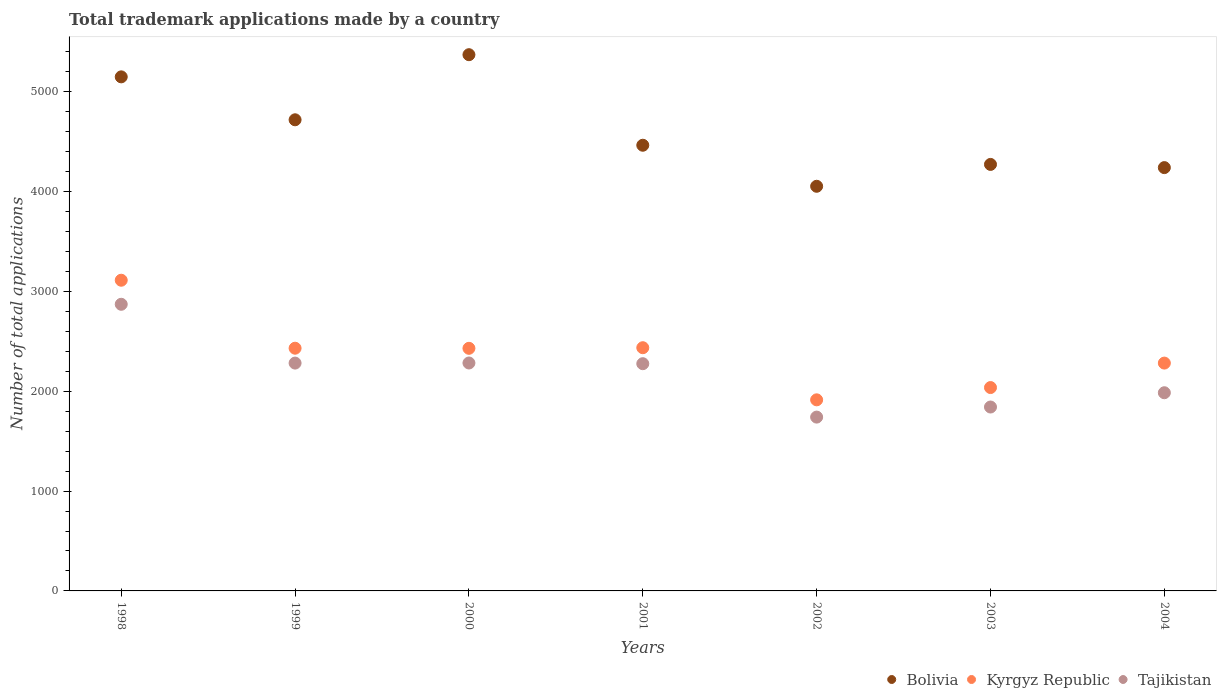Is the number of dotlines equal to the number of legend labels?
Provide a succinct answer. Yes. What is the number of applications made by in Bolivia in 2002?
Provide a succinct answer. 4053. Across all years, what is the maximum number of applications made by in Kyrgyz Republic?
Your answer should be compact. 3112. Across all years, what is the minimum number of applications made by in Tajikistan?
Make the answer very short. 1741. In which year was the number of applications made by in Kyrgyz Republic minimum?
Your answer should be very brief. 2002. What is the total number of applications made by in Kyrgyz Republic in the graph?
Provide a succinct answer. 1.66e+04. What is the difference between the number of applications made by in Tajikistan in 2000 and that in 2003?
Provide a short and direct response. 441. What is the difference between the number of applications made by in Bolivia in 1999 and the number of applications made by in Kyrgyz Republic in 2001?
Provide a short and direct response. 2283. What is the average number of applications made by in Bolivia per year?
Give a very brief answer. 4609.71. In the year 2001, what is the difference between the number of applications made by in Bolivia and number of applications made by in Tajikistan?
Your answer should be compact. 2188. In how many years, is the number of applications made by in Tajikistan greater than 600?
Keep it short and to the point. 7. What is the ratio of the number of applications made by in Bolivia in 1998 to that in 2002?
Offer a very short reply. 1.27. Is the difference between the number of applications made by in Bolivia in 1998 and 1999 greater than the difference between the number of applications made by in Tajikistan in 1998 and 1999?
Ensure brevity in your answer.  No. What is the difference between the highest and the second highest number of applications made by in Kyrgyz Republic?
Offer a very short reply. 676. What is the difference between the highest and the lowest number of applications made by in Tajikistan?
Your answer should be very brief. 1130. In how many years, is the number of applications made by in Tajikistan greater than the average number of applications made by in Tajikistan taken over all years?
Offer a terse response. 4. Is the number of applications made by in Tajikistan strictly less than the number of applications made by in Kyrgyz Republic over the years?
Your response must be concise. Yes. Does the graph contain any zero values?
Make the answer very short. No. Where does the legend appear in the graph?
Give a very brief answer. Bottom right. How many legend labels are there?
Keep it short and to the point. 3. How are the legend labels stacked?
Provide a succinct answer. Horizontal. What is the title of the graph?
Offer a very short reply. Total trademark applications made by a country. Does "Middle East & North Africa (developing only)" appear as one of the legend labels in the graph?
Keep it short and to the point. No. What is the label or title of the X-axis?
Provide a short and direct response. Years. What is the label or title of the Y-axis?
Your answer should be very brief. Number of total applications. What is the Number of total applications in Bolivia in 1998?
Keep it short and to the point. 5149. What is the Number of total applications of Kyrgyz Republic in 1998?
Give a very brief answer. 3112. What is the Number of total applications of Tajikistan in 1998?
Provide a short and direct response. 2871. What is the Number of total applications in Bolivia in 1999?
Offer a terse response. 4719. What is the Number of total applications of Kyrgyz Republic in 1999?
Offer a terse response. 2431. What is the Number of total applications of Tajikistan in 1999?
Provide a short and direct response. 2282. What is the Number of total applications of Bolivia in 2000?
Keep it short and to the point. 5371. What is the Number of total applications in Kyrgyz Republic in 2000?
Keep it short and to the point. 2430. What is the Number of total applications in Tajikistan in 2000?
Your answer should be very brief. 2283. What is the Number of total applications of Bolivia in 2001?
Offer a very short reply. 4464. What is the Number of total applications of Kyrgyz Republic in 2001?
Provide a succinct answer. 2436. What is the Number of total applications of Tajikistan in 2001?
Your answer should be compact. 2276. What is the Number of total applications of Bolivia in 2002?
Provide a succinct answer. 4053. What is the Number of total applications in Kyrgyz Republic in 2002?
Your answer should be very brief. 1914. What is the Number of total applications of Tajikistan in 2002?
Give a very brief answer. 1741. What is the Number of total applications of Bolivia in 2003?
Provide a short and direct response. 4272. What is the Number of total applications in Kyrgyz Republic in 2003?
Offer a very short reply. 2037. What is the Number of total applications in Tajikistan in 2003?
Keep it short and to the point. 1842. What is the Number of total applications of Bolivia in 2004?
Your answer should be very brief. 4240. What is the Number of total applications of Kyrgyz Republic in 2004?
Make the answer very short. 2282. What is the Number of total applications in Tajikistan in 2004?
Provide a short and direct response. 1985. Across all years, what is the maximum Number of total applications of Bolivia?
Ensure brevity in your answer.  5371. Across all years, what is the maximum Number of total applications in Kyrgyz Republic?
Ensure brevity in your answer.  3112. Across all years, what is the maximum Number of total applications in Tajikistan?
Offer a very short reply. 2871. Across all years, what is the minimum Number of total applications in Bolivia?
Your answer should be compact. 4053. Across all years, what is the minimum Number of total applications of Kyrgyz Republic?
Provide a succinct answer. 1914. Across all years, what is the minimum Number of total applications of Tajikistan?
Your answer should be very brief. 1741. What is the total Number of total applications in Bolivia in the graph?
Give a very brief answer. 3.23e+04. What is the total Number of total applications in Kyrgyz Republic in the graph?
Your answer should be compact. 1.66e+04. What is the total Number of total applications of Tajikistan in the graph?
Your response must be concise. 1.53e+04. What is the difference between the Number of total applications of Bolivia in 1998 and that in 1999?
Your answer should be very brief. 430. What is the difference between the Number of total applications of Kyrgyz Republic in 1998 and that in 1999?
Offer a very short reply. 681. What is the difference between the Number of total applications of Tajikistan in 1998 and that in 1999?
Keep it short and to the point. 589. What is the difference between the Number of total applications of Bolivia in 1998 and that in 2000?
Provide a short and direct response. -222. What is the difference between the Number of total applications in Kyrgyz Republic in 1998 and that in 2000?
Give a very brief answer. 682. What is the difference between the Number of total applications of Tajikistan in 1998 and that in 2000?
Provide a short and direct response. 588. What is the difference between the Number of total applications of Bolivia in 1998 and that in 2001?
Ensure brevity in your answer.  685. What is the difference between the Number of total applications in Kyrgyz Republic in 1998 and that in 2001?
Make the answer very short. 676. What is the difference between the Number of total applications of Tajikistan in 1998 and that in 2001?
Your answer should be compact. 595. What is the difference between the Number of total applications in Bolivia in 1998 and that in 2002?
Provide a short and direct response. 1096. What is the difference between the Number of total applications in Kyrgyz Republic in 1998 and that in 2002?
Your answer should be very brief. 1198. What is the difference between the Number of total applications of Tajikistan in 1998 and that in 2002?
Keep it short and to the point. 1130. What is the difference between the Number of total applications in Bolivia in 1998 and that in 2003?
Give a very brief answer. 877. What is the difference between the Number of total applications of Kyrgyz Republic in 1998 and that in 2003?
Keep it short and to the point. 1075. What is the difference between the Number of total applications in Tajikistan in 1998 and that in 2003?
Provide a short and direct response. 1029. What is the difference between the Number of total applications of Bolivia in 1998 and that in 2004?
Provide a short and direct response. 909. What is the difference between the Number of total applications in Kyrgyz Republic in 1998 and that in 2004?
Your answer should be compact. 830. What is the difference between the Number of total applications of Tajikistan in 1998 and that in 2004?
Your response must be concise. 886. What is the difference between the Number of total applications in Bolivia in 1999 and that in 2000?
Provide a succinct answer. -652. What is the difference between the Number of total applications in Kyrgyz Republic in 1999 and that in 2000?
Provide a succinct answer. 1. What is the difference between the Number of total applications of Tajikistan in 1999 and that in 2000?
Your answer should be compact. -1. What is the difference between the Number of total applications in Bolivia in 1999 and that in 2001?
Your answer should be compact. 255. What is the difference between the Number of total applications in Kyrgyz Republic in 1999 and that in 2001?
Make the answer very short. -5. What is the difference between the Number of total applications of Bolivia in 1999 and that in 2002?
Give a very brief answer. 666. What is the difference between the Number of total applications in Kyrgyz Republic in 1999 and that in 2002?
Your response must be concise. 517. What is the difference between the Number of total applications of Tajikistan in 1999 and that in 2002?
Provide a succinct answer. 541. What is the difference between the Number of total applications of Bolivia in 1999 and that in 2003?
Ensure brevity in your answer.  447. What is the difference between the Number of total applications in Kyrgyz Republic in 1999 and that in 2003?
Your answer should be very brief. 394. What is the difference between the Number of total applications of Tajikistan in 1999 and that in 2003?
Ensure brevity in your answer.  440. What is the difference between the Number of total applications in Bolivia in 1999 and that in 2004?
Provide a short and direct response. 479. What is the difference between the Number of total applications of Kyrgyz Republic in 1999 and that in 2004?
Provide a succinct answer. 149. What is the difference between the Number of total applications of Tajikistan in 1999 and that in 2004?
Your answer should be very brief. 297. What is the difference between the Number of total applications in Bolivia in 2000 and that in 2001?
Provide a short and direct response. 907. What is the difference between the Number of total applications of Tajikistan in 2000 and that in 2001?
Offer a very short reply. 7. What is the difference between the Number of total applications of Bolivia in 2000 and that in 2002?
Give a very brief answer. 1318. What is the difference between the Number of total applications in Kyrgyz Republic in 2000 and that in 2002?
Provide a short and direct response. 516. What is the difference between the Number of total applications of Tajikistan in 2000 and that in 2002?
Offer a terse response. 542. What is the difference between the Number of total applications in Bolivia in 2000 and that in 2003?
Offer a very short reply. 1099. What is the difference between the Number of total applications in Kyrgyz Republic in 2000 and that in 2003?
Offer a terse response. 393. What is the difference between the Number of total applications of Tajikistan in 2000 and that in 2003?
Offer a very short reply. 441. What is the difference between the Number of total applications of Bolivia in 2000 and that in 2004?
Provide a succinct answer. 1131. What is the difference between the Number of total applications of Kyrgyz Republic in 2000 and that in 2004?
Keep it short and to the point. 148. What is the difference between the Number of total applications of Tajikistan in 2000 and that in 2004?
Your answer should be very brief. 298. What is the difference between the Number of total applications of Bolivia in 2001 and that in 2002?
Offer a terse response. 411. What is the difference between the Number of total applications of Kyrgyz Republic in 2001 and that in 2002?
Offer a very short reply. 522. What is the difference between the Number of total applications of Tajikistan in 2001 and that in 2002?
Your answer should be compact. 535. What is the difference between the Number of total applications of Bolivia in 2001 and that in 2003?
Keep it short and to the point. 192. What is the difference between the Number of total applications of Kyrgyz Republic in 2001 and that in 2003?
Your response must be concise. 399. What is the difference between the Number of total applications in Tajikistan in 2001 and that in 2003?
Your answer should be very brief. 434. What is the difference between the Number of total applications in Bolivia in 2001 and that in 2004?
Ensure brevity in your answer.  224. What is the difference between the Number of total applications in Kyrgyz Republic in 2001 and that in 2004?
Offer a very short reply. 154. What is the difference between the Number of total applications in Tajikistan in 2001 and that in 2004?
Your response must be concise. 291. What is the difference between the Number of total applications of Bolivia in 2002 and that in 2003?
Keep it short and to the point. -219. What is the difference between the Number of total applications of Kyrgyz Republic in 2002 and that in 2003?
Your answer should be very brief. -123. What is the difference between the Number of total applications of Tajikistan in 2002 and that in 2003?
Make the answer very short. -101. What is the difference between the Number of total applications in Bolivia in 2002 and that in 2004?
Provide a short and direct response. -187. What is the difference between the Number of total applications in Kyrgyz Republic in 2002 and that in 2004?
Ensure brevity in your answer.  -368. What is the difference between the Number of total applications in Tajikistan in 2002 and that in 2004?
Your response must be concise. -244. What is the difference between the Number of total applications in Bolivia in 2003 and that in 2004?
Make the answer very short. 32. What is the difference between the Number of total applications in Kyrgyz Republic in 2003 and that in 2004?
Your answer should be very brief. -245. What is the difference between the Number of total applications of Tajikistan in 2003 and that in 2004?
Give a very brief answer. -143. What is the difference between the Number of total applications in Bolivia in 1998 and the Number of total applications in Kyrgyz Republic in 1999?
Your answer should be compact. 2718. What is the difference between the Number of total applications of Bolivia in 1998 and the Number of total applications of Tajikistan in 1999?
Your answer should be compact. 2867. What is the difference between the Number of total applications of Kyrgyz Republic in 1998 and the Number of total applications of Tajikistan in 1999?
Offer a terse response. 830. What is the difference between the Number of total applications of Bolivia in 1998 and the Number of total applications of Kyrgyz Republic in 2000?
Your response must be concise. 2719. What is the difference between the Number of total applications of Bolivia in 1998 and the Number of total applications of Tajikistan in 2000?
Give a very brief answer. 2866. What is the difference between the Number of total applications in Kyrgyz Republic in 1998 and the Number of total applications in Tajikistan in 2000?
Make the answer very short. 829. What is the difference between the Number of total applications in Bolivia in 1998 and the Number of total applications in Kyrgyz Republic in 2001?
Ensure brevity in your answer.  2713. What is the difference between the Number of total applications of Bolivia in 1998 and the Number of total applications of Tajikistan in 2001?
Provide a short and direct response. 2873. What is the difference between the Number of total applications in Kyrgyz Republic in 1998 and the Number of total applications in Tajikistan in 2001?
Keep it short and to the point. 836. What is the difference between the Number of total applications of Bolivia in 1998 and the Number of total applications of Kyrgyz Republic in 2002?
Make the answer very short. 3235. What is the difference between the Number of total applications of Bolivia in 1998 and the Number of total applications of Tajikistan in 2002?
Offer a terse response. 3408. What is the difference between the Number of total applications of Kyrgyz Republic in 1998 and the Number of total applications of Tajikistan in 2002?
Offer a terse response. 1371. What is the difference between the Number of total applications in Bolivia in 1998 and the Number of total applications in Kyrgyz Republic in 2003?
Your answer should be very brief. 3112. What is the difference between the Number of total applications in Bolivia in 1998 and the Number of total applications in Tajikistan in 2003?
Keep it short and to the point. 3307. What is the difference between the Number of total applications of Kyrgyz Republic in 1998 and the Number of total applications of Tajikistan in 2003?
Provide a short and direct response. 1270. What is the difference between the Number of total applications in Bolivia in 1998 and the Number of total applications in Kyrgyz Republic in 2004?
Give a very brief answer. 2867. What is the difference between the Number of total applications of Bolivia in 1998 and the Number of total applications of Tajikistan in 2004?
Give a very brief answer. 3164. What is the difference between the Number of total applications in Kyrgyz Republic in 1998 and the Number of total applications in Tajikistan in 2004?
Provide a succinct answer. 1127. What is the difference between the Number of total applications in Bolivia in 1999 and the Number of total applications in Kyrgyz Republic in 2000?
Your answer should be very brief. 2289. What is the difference between the Number of total applications of Bolivia in 1999 and the Number of total applications of Tajikistan in 2000?
Make the answer very short. 2436. What is the difference between the Number of total applications in Kyrgyz Republic in 1999 and the Number of total applications in Tajikistan in 2000?
Offer a very short reply. 148. What is the difference between the Number of total applications of Bolivia in 1999 and the Number of total applications of Kyrgyz Republic in 2001?
Provide a succinct answer. 2283. What is the difference between the Number of total applications of Bolivia in 1999 and the Number of total applications of Tajikistan in 2001?
Your response must be concise. 2443. What is the difference between the Number of total applications of Kyrgyz Republic in 1999 and the Number of total applications of Tajikistan in 2001?
Your answer should be very brief. 155. What is the difference between the Number of total applications in Bolivia in 1999 and the Number of total applications in Kyrgyz Republic in 2002?
Offer a very short reply. 2805. What is the difference between the Number of total applications in Bolivia in 1999 and the Number of total applications in Tajikistan in 2002?
Your answer should be very brief. 2978. What is the difference between the Number of total applications of Kyrgyz Republic in 1999 and the Number of total applications of Tajikistan in 2002?
Your answer should be compact. 690. What is the difference between the Number of total applications in Bolivia in 1999 and the Number of total applications in Kyrgyz Republic in 2003?
Your response must be concise. 2682. What is the difference between the Number of total applications in Bolivia in 1999 and the Number of total applications in Tajikistan in 2003?
Your answer should be very brief. 2877. What is the difference between the Number of total applications of Kyrgyz Republic in 1999 and the Number of total applications of Tajikistan in 2003?
Your response must be concise. 589. What is the difference between the Number of total applications of Bolivia in 1999 and the Number of total applications of Kyrgyz Republic in 2004?
Your response must be concise. 2437. What is the difference between the Number of total applications of Bolivia in 1999 and the Number of total applications of Tajikistan in 2004?
Offer a very short reply. 2734. What is the difference between the Number of total applications in Kyrgyz Republic in 1999 and the Number of total applications in Tajikistan in 2004?
Provide a succinct answer. 446. What is the difference between the Number of total applications of Bolivia in 2000 and the Number of total applications of Kyrgyz Republic in 2001?
Provide a short and direct response. 2935. What is the difference between the Number of total applications of Bolivia in 2000 and the Number of total applications of Tajikistan in 2001?
Your answer should be very brief. 3095. What is the difference between the Number of total applications of Kyrgyz Republic in 2000 and the Number of total applications of Tajikistan in 2001?
Provide a succinct answer. 154. What is the difference between the Number of total applications of Bolivia in 2000 and the Number of total applications of Kyrgyz Republic in 2002?
Keep it short and to the point. 3457. What is the difference between the Number of total applications of Bolivia in 2000 and the Number of total applications of Tajikistan in 2002?
Provide a succinct answer. 3630. What is the difference between the Number of total applications of Kyrgyz Republic in 2000 and the Number of total applications of Tajikistan in 2002?
Provide a short and direct response. 689. What is the difference between the Number of total applications in Bolivia in 2000 and the Number of total applications in Kyrgyz Republic in 2003?
Keep it short and to the point. 3334. What is the difference between the Number of total applications in Bolivia in 2000 and the Number of total applications in Tajikistan in 2003?
Offer a very short reply. 3529. What is the difference between the Number of total applications in Kyrgyz Republic in 2000 and the Number of total applications in Tajikistan in 2003?
Make the answer very short. 588. What is the difference between the Number of total applications of Bolivia in 2000 and the Number of total applications of Kyrgyz Republic in 2004?
Your answer should be compact. 3089. What is the difference between the Number of total applications in Bolivia in 2000 and the Number of total applications in Tajikistan in 2004?
Offer a very short reply. 3386. What is the difference between the Number of total applications in Kyrgyz Republic in 2000 and the Number of total applications in Tajikistan in 2004?
Your response must be concise. 445. What is the difference between the Number of total applications in Bolivia in 2001 and the Number of total applications in Kyrgyz Republic in 2002?
Your response must be concise. 2550. What is the difference between the Number of total applications of Bolivia in 2001 and the Number of total applications of Tajikistan in 2002?
Provide a short and direct response. 2723. What is the difference between the Number of total applications in Kyrgyz Republic in 2001 and the Number of total applications in Tajikistan in 2002?
Provide a succinct answer. 695. What is the difference between the Number of total applications in Bolivia in 2001 and the Number of total applications in Kyrgyz Republic in 2003?
Ensure brevity in your answer.  2427. What is the difference between the Number of total applications in Bolivia in 2001 and the Number of total applications in Tajikistan in 2003?
Give a very brief answer. 2622. What is the difference between the Number of total applications in Kyrgyz Republic in 2001 and the Number of total applications in Tajikistan in 2003?
Offer a very short reply. 594. What is the difference between the Number of total applications of Bolivia in 2001 and the Number of total applications of Kyrgyz Republic in 2004?
Keep it short and to the point. 2182. What is the difference between the Number of total applications of Bolivia in 2001 and the Number of total applications of Tajikistan in 2004?
Your response must be concise. 2479. What is the difference between the Number of total applications in Kyrgyz Republic in 2001 and the Number of total applications in Tajikistan in 2004?
Your answer should be very brief. 451. What is the difference between the Number of total applications in Bolivia in 2002 and the Number of total applications in Kyrgyz Republic in 2003?
Your answer should be very brief. 2016. What is the difference between the Number of total applications of Bolivia in 2002 and the Number of total applications of Tajikistan in 2003?
Your response must be concise. 2211. What is the difference between the Number of total applications in Bolivia in 2002 and the Number of total applications in Kyrgyz Republic in 2004?
Provide a succinct answer. 1771. What is the difference between the Number of total applications of Bolivia in 2002 and the Number of total applications of Tajikistan in 2004?
Give a very brief answer. 2068. What is the difference between the Number of total applications in Kyrgyz Republic in 2002 and the Number of total applications in Tajikistan in 2004?
Your answer should be very brief. -71. What is the difference between the Number of total applications in Bolivia in 2003 and the Number of total applications in Kyrgyz Republic in 2004?
Your answer should be very brief. 1990. What is the difference between the Number of total applications of Bolivia in 2003 and the Number of total applications of Tajikistan in 2004?
Provide a succinct answer. 2287. What is the average Number of total applications in Bolivia per year?
Your answer should be very brief. 4609.71. What is the average Number of total applications of Kyrgyz Republic per year?
Your answer should be compact. 2377.43. What is the average Number of total applications of Tajikistan per year?
Ensure brevity in your answer.  2182.86. In the year 1998, what is the difference between the Number of total applications in Bolivia and Number of total applications in Kyrgyz Republic?
Provide a succinct answer. 2037. In the year 1998, what is the difference between the Number of total applications in Bolivia and Number of total applications in Tajikistan?
Your answer should be very brief. 2278. In the year 1998, what is the difference between the Number of total applications of Kyrgyz Republic and Number of total applications of Tajikistan?
Your answer should be compact. 241. In the year 1999, what is the difference between the Number of total applications of Bolivia and Number of total applications of Kyrgyz Republic?
Your answer should be compact. 2288. In the year 1999, what is the difference between the Number of total applications of Bolivia and Number of total applications of Tajikistan?
Provide a succinct answer. 2437. In the year 1999, what is the difference between the Number of total applications of Kyrgyz Republic and Number of total applications of Tajikistan?
Provide a short and direct response. 149. In the year 2000, what is the difference between the Number of total applications in Bolivia and Number of total applications in Kyrgyz Republic?
Keep it short and to the point. 2941. In the year 2000, what is the difference between the Number of total applications in Bolivia and Number of total applications in Tajikistan?
Provide a short and direct response. 3088. In the year 2000, what is the difference between the Number of total applications of Kyrgyz Republic and Number of total applications of Tajikistan?
Keep it short and to the point. 147. In the year 2001, what is the difference between the Number of total applications of Bolivia and Number of total applications of Kyrgyz Republic?
Provide a short and direct response. 2028. In the year 2001, what is the difference between the Number of total applications of Bolivia and Number of total applications of Tajikistan?
Your answer should be compact. 2188. In the year 2001, what is the difference between the Number of total applications in Kyrgyz Republic and Number of total applications in Tajikistan?
Provide a short and direct response. 160. In the year 2002, what is the difference between the Number of total applications in Bolivia and Number of total applications in Kyrgyz Republic?
Your answer should be very brief. 2139. In the year 2002, what is the difference between the Number of total applications in Bolivia and Number of total applications in Tajikistan?
Make the answer very short. 2312. In the year 2002, what is the difference between the Number of total applications of Kyrgyz Republic and Number of total applications of Tajikistan?
Keep it short and to the point. 173. In the year 2003, what is the difference between the Number of total applications of Bolivia and Number of total applications of Kyrgyz Republic?
Provide a succinct answer. 2235. In the year 2003, what is the difference between the Number of total applications of Bolivia and Number of total applications of Tajikistan?
Offer a terse response. 2430. In the year 2003, what is the difference between the Number of total applications in Kyrgyz Republic and Number of total applications in Tajikistan?
Provide a succinct answer. 195. In the year 2004, what is the difference between the Number of total applications in Bolivia and Number of total applications in Kyrgyz Republic?
Ensure brevity in your answer.  1958. In the year 2004, what is the difference between the Number of total applications of Bolivia and Number of total applications of Tajikistan?
Your response must be concise. 2255. In the year 2004, what is the difference between the Number of total applications of Kyrgyz Republic and Number of total applications of Tajikistan?
Offer a terse response. 297. What is the ratio of the Number of total applications of Bolivia in 1998 to that in 1999?
Your response must be concise. 1.09. What is the ratio of the Number of total applications of Kyrgyz Republic in 1998 to that in 1999?
Ensure brevity in your answer.  1.28. What is the ratio of the Number of total applications in Tajikistan in 1998 to that in 1999?
Provide a succinct answer. 1.26. What is the ratio of the Number of total applications of Bolivia in 1998 to that in 2000?
Your response must be concise. 0.96. What is the ratio of the Number of total applications of Kyrgyz Republic in 1998 to that in 2000?
Your answer should be compact. 1.28. What is the ratio of the Number of total applications of Tajikistan in 1998 to that in 2000?
Ensure brevity in your answer.  1.26. What is the ratio of the Number of total applications of Bolivia in 1998 to that in 2001?
Make the answer very short. 1.15. What is the ratio of the Number of total applications in Kyrgyz Republic in 1998 to that in 2001?
Ensure brevity in your answer.  1.28. What is the ratio of the Number of total applications of Tajikistan in 1998 to that in 2001?
Provide a short and direct response. 1.26. What is the ratio of the Number of total applications in Bolivia in 1998 to that in 2002?
Provide a short and direct response. 1.27. What is the ratio of the Number of total applications of Kyrgyz Republic in 1998 to that in 2002?
Keep it short and to the point. 1.63. What is the ratio of the Number of total applications of Tajikistan in 1998 to that in 2002?
Make the answer very short. 1.65. What is the ratio of the Number of total applications in Bolivia in 1998 to that in 2003?
Provide a succinct answer. 1.21. What is the ratio of the Number of total applications in Kyrgyz Republic in 1998 to that in 2003?
Offer a very short reply. 1.53. What is the ratio of the Number of total applications in Tajikistan in 1998 to that in 2003?
Your answer should be compact. 1.56. What is the ratio of the Number of total applications of Bolivia in 1998 to that in 2004?
Provide a short and direct response. 1.21. What is the ratio of the Number of total applications of Kyrgyz Republic in 1998 to that in 2004?
Provide a succinct answer. 1.36. What is the ratio of the Number of total applications of Tajikistan in 1998 to that in 2004?
Your answer should be very brief. 1.45. What is the ratio of the Number of total applications of Bolivia in 1999 to that in 2000?
Your response must be concise. 0.88. What is the ratio of the Number of total applications in Kyrgyz Republic in 1999 to that in 2000?
Give a very brief answer. 1. What is the ratio of the Number of total applications of Tajikistan in 1999 to that in 2000?
Provide a short and direct response. 1. What is the ratio of the Number of total applications in Bolivia in 1999 to that in 2001?
Provide a succinct answer. 1.06. What is the ratio of the Number of total applications of Tajikistan in 1999 to that in 2001?
Provide a short and direct response. 1. What is the ratio of the Number of total applications of Bolivia in 1999 to that in 2002?
Offer a very short reply. 1.16. What is the ratio of the Number of total applications in Kyrgyz Republic in 1999 to that in 2002?
Your answer should be very brief. 1.27. What is the ratio of the Number of total applications in Tajikistan in 1999 to that in 2002?
Offer a very short reply. 1.31. What is the ratio of the Number of total applications of Bolivia in 1999 to that in 2003?
Provide a succinct answer. 1.1. What is the ratio of the Number of total applications of Kyrgyz Republic in 1999 to that in 2003?
Offer a very short reply. 1.19. What is the ratio of the Number of total applications in Tajikistan in 1999 to that in 2003?
Offer a terse response. 1.24. What is the ratio of the Number of total applications in Bolivia in 1999 to that in 2004?
Give a very brief answer. 1.11. What is the ratio of the Number of total applications of Kyrgyz Republic in 1999 to that in 2004?
Your response must be concise. 1.07. What is the ratio of the Number of total applications in Tajikistan in 1999 to that in 2004?
Offer a very short reply. 1.15. What is the ratio of the Number of total applications of Bolivia in 2000 to that in 2001?
Offer a very short reply. 1.2. What is the ratio of the Number of total applications in Kyrgyz Republic in 2000 to that in 2001?
Your response must be concise. 1. What is the ratio of the Number of total applications of Bolivia in 2000 to that in 2002?
Make the answer very short. 1.33. What is the ratio of the Number of total applications in Kyrgyz Republic in 2000 to that in 2002?
Offer a very short reply. 1.27. What is the ratio of the Number of total applications in Tajikistan in 2000 to that in 2002?
Make the answer very short. 1.31. What is the ratio of the Number of total applications in Bolivia in 2000 to that in 2003?
Offer a very short reply. 1.26. What is the ratio of the Number of total applications in Kyrgyz Republic in 2000 to that in 2003?
Your response must be concise. 1.19. What is the ratio of the Number of total applications of Tajikistan in 2000 to that in 2003?
Offer a terse response. 1.24. What is the ratio of the Number of total applications of Bolivia in 2000 to that in 2004?
Your answer should be very brief. 1.27. What is the ratio of the Number of total applications of Kyrgyz Republic in 2000 to that in 2004?
Your answer should be very brief. 1.06. What is the ratio of the Number of total applications in Tajikistan in 2000 to that in 2004?
Ensure brevity in your answer.  1.15. What is the ratio of the Number of total applications in Bolivia in 2001 to that in 2002?
Offer a terse response. 1.1. What is the ratio of the Number of total applications of Kyrgyz Republic in 2001 to that in 2002?
Offer a terse response. 1.27. What is the ratio of the Number of total applications of Tajikistan in 2001 to that in 2002?
Give a very brief answer. 1.31. What is the ratio of the Number of total applications of Bolivia in 2001 to that in 2003?
Provide a short and direct response. 1.04. What is the ratio of the Number of total applications in Kyrgyz Republic in 2001 to that in 2003?
Your response must be concise. 1.2. What is the ratio of the Number of total applications in Tajikistan in 2001 to that in 2003?
Provide a short and direct response. 1.24. What is the ratio of the Number of total applications in Bolivia in 2001 to that in 2004?
Provide a short and direct response. 1.05. What is the ratio of the Number of total applications in Kyrgyz Republic in 2001 to that in 2004?
Give a very brief answer. 1.07. What is the ratio of the Number of total applications of Tajikistan in 2001 to that in 2004?
Ensure brevity in your answer.  1.15. What is the ratio of the Number of total applications in Bolivia in 2002 to that in 2003?
Offer a terse response. 0.95. What is the ratio of the Number of total applications of Kyrgyz Republic in 2002 to that in 2003?
Give a very brief answer. 0.94. What is the ratio of the Number of total applications of Tajikistan in 2002 to that in 2003?
Ensure brevity in your answer.  0.95. What is the ratio of the Number of total applications of Bolivia in 2002 to that in 2004?
Your answer should be very brief. 0.96. What is the ratio of the Number of total applications of Kyrgyz Republic in 2002 to that in 2004?
Ensure brevity in your answer.  0.84. What is the ratio of the Number of total applications in Tajikistan in 2002 to that in 2004?
Your answer should be compact. 0.88. What is the ratio of the Number of total applications in Bolivia in 2003 to that in 2004?
Ensure brevity in your answer.  1.01. What is the ratio of the Number of total applications of Kyrgyz Republic in 2003 to that in 2004?
Your answer should be compact. 0.89. What is the ratio of the Number of total applications of Tajikistan in 2003 to that in 2004?
Ensure brevity in your answer.  0.93. What is the difference between the highest and the second highest Number of total applications in Bolivia?
Offer a very short reply. 222. What is the difference between the highest and the second highest Number of total applications of Kyrgyz Republic?
Make the answer very short. 676. What is the difference between the highest and the second highest Number of total applications of Tajikistan?
Make the answer very short. 588. What is the difference between the highest and the lowest Number of total applications of Bolivia?
Give a very brief answer. 1318. What is the difference between the highest and the lowest Number of total applications of Kyrgyz Republic?
Your response must be concise. 1198. What is the difference between the highest and the lowest Number of total applications of Tajikistan?
Your answer should be compact. 1130. 